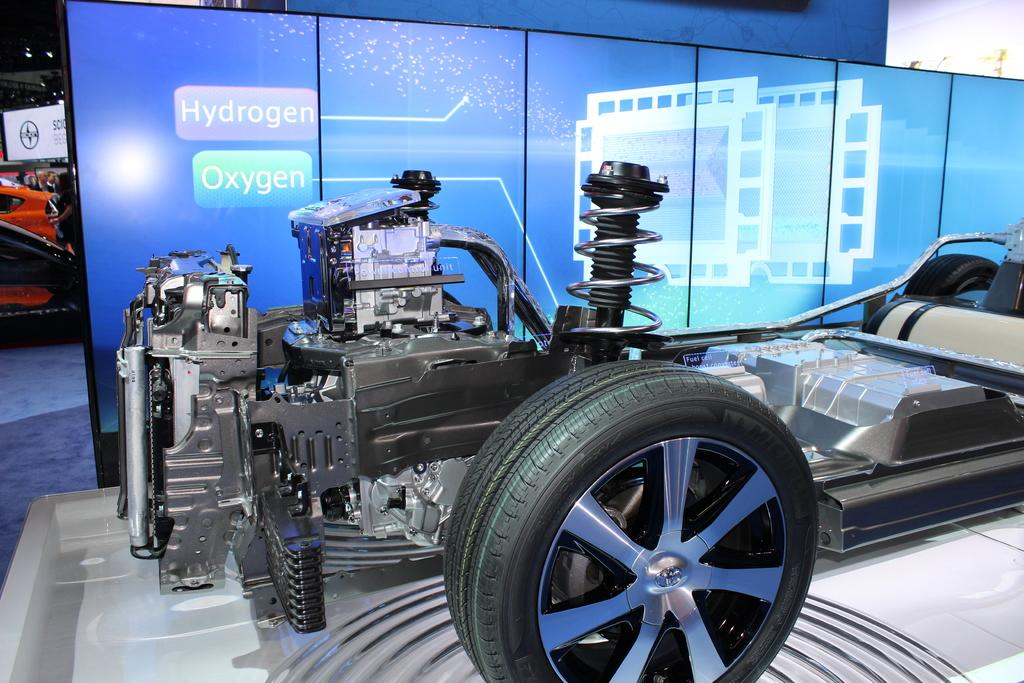What type of vehicle is shown in the image? The image shows the inside part of a sports car. What can be seen under the hood of the sports car? There is an engine visible in the image. What other mechanical components are present in the image? There are other machines present in the image. Can you describe the tires in the image? A tire is visible in the image. What is provided for the driver to sit on? There is a seat in the image. What separates the driver's area from the rest of the car? There is a partition wall in the image. Are there any other vehicles visible in the image? Yes, there is another red color car in the image. How many trees can be seen growing inside the sports car in the image? There are no trees visible inside the sports car in the image. 